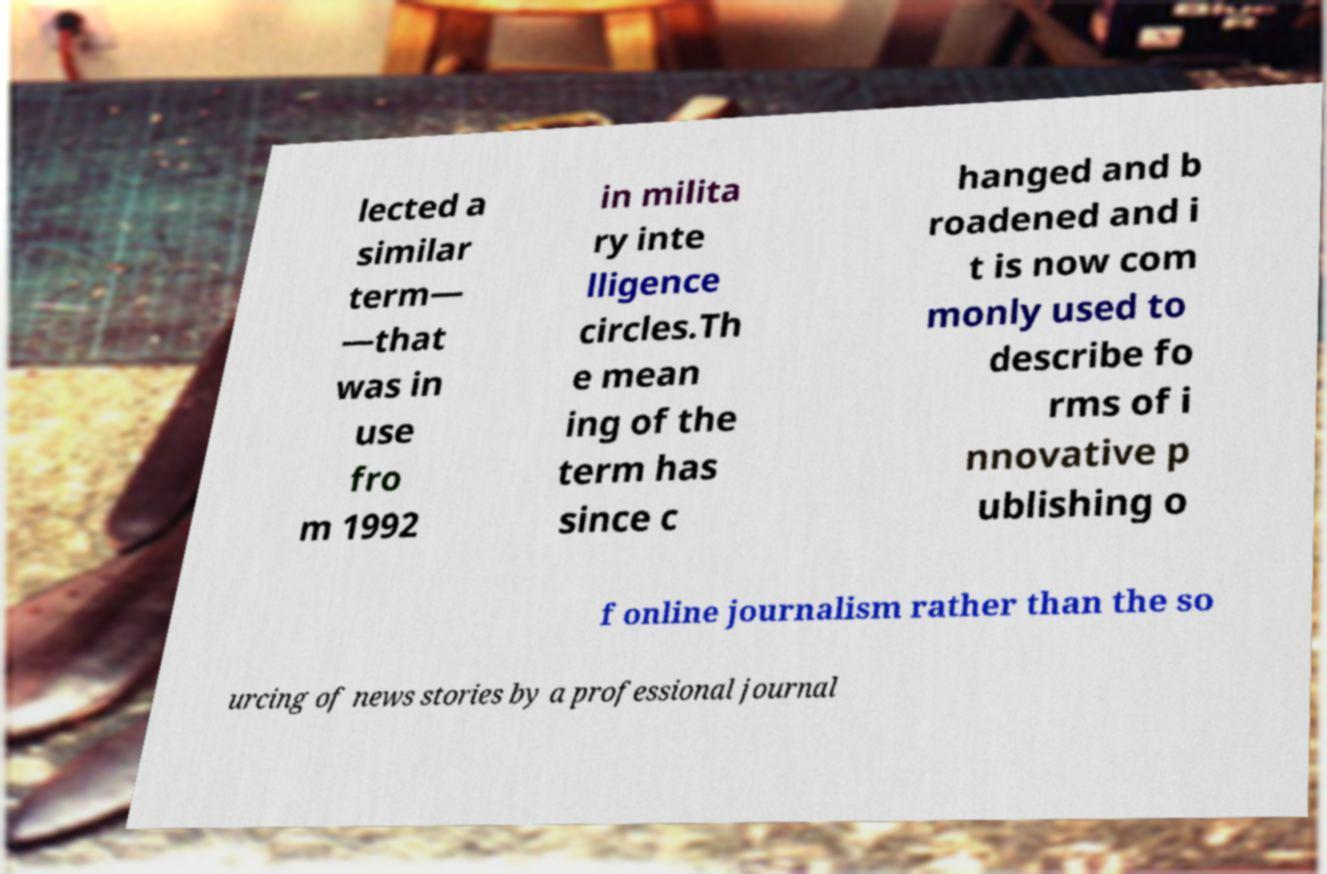I need the written content from this picture converted into text. Can you do that? lected a similar term— —that was in use fro m 1992 in milita ry inte lligence circles.Th e mean ing of the term has since c hanged and b roadened and i t is now com monly used to describe fo rms of i nnovative p ublishing o f online journalism rather than the so urcing of news stories by a professional journal 